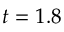Convert formula to latex. <formula><loc_0><loc_0><loc_500><loc_500>t = 1 . 8</formula> 